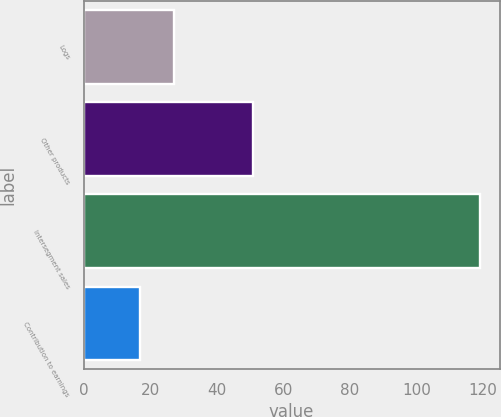Convert chart to OTSL. <chart><loc_0><loc_0><loc_500><loc_500><bar_chart><fcel>Logs<fcel>Other products<fcel>Intersegment sales<fcel>Contribution to earnings<nl><fcel>27.2<fcel>51<fcel>119<fcel>17<nl></chart> 